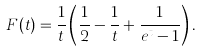<formula> <loc_0><loc_0><loc_500><loc_500>F ( t ) = \frac { 1 } { t } \left ( \frac { 1 } { 2 } - \frac { 1 } { t } + \frac { 1 } { e ^ { t } - 1 } \right ) .</formula> 